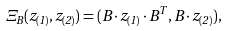Convert formula to latex. <formula><loc_0><loc_0><loc_500><loc_500>\Xi _ { B } ( z _ { ( 1 ) } , z _ { ( 2 ) } ) = ( B \cdot z _ { ( 1 ) } \cdot B ^ { T } , B \cdot z _ { ( 2 ) } ) ,</formula> 